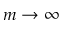<formula> <loc_0><loc_0><loc_500><loc_500>m \rightarrow \infty</formula> 